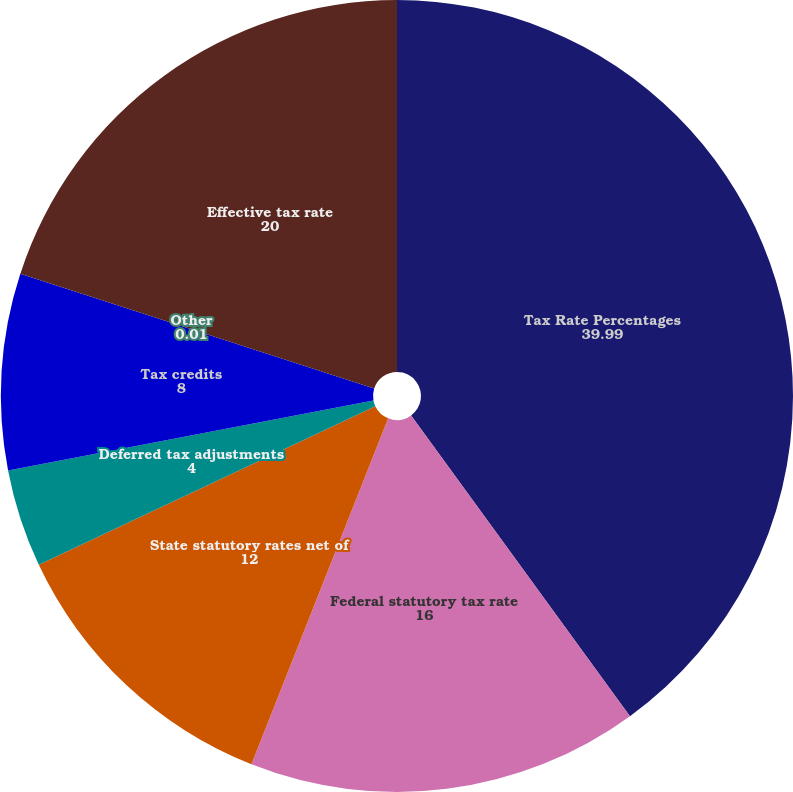<chart> <loc_0><loc_0><loc_500><loc_500><pie_chart><fcel>Tax Rate Percentages<fcel>Federal statutory tax rate<fcel>State statutory rates net of<fcel>Deferred tax adjustments<fcel>Tax credits<fcel>Other<fcel>Effective tax rate<nl><fcel>39.99%<fcel>16.0%<fcel>12.0%<fcel>4.0%<fcel>8.0%<fcel>0.01%<fcel>20.0%<nl></chart> 